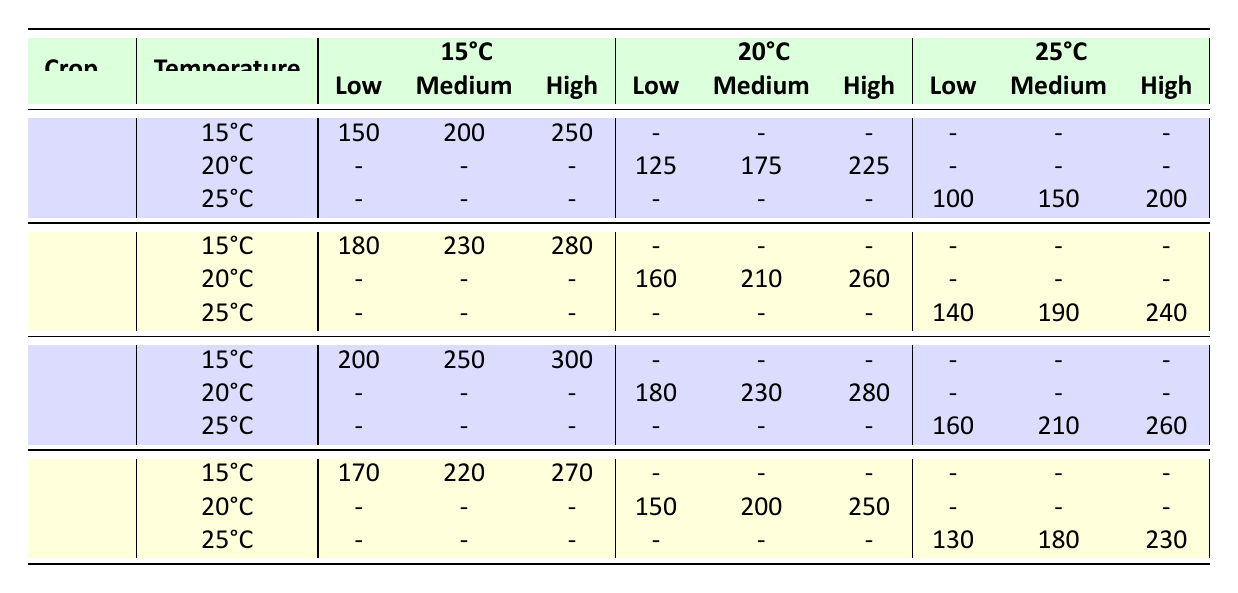What's the life expectancy of Maize under low precipitation at 15°C? According to the table, for Maize under the temperature scenario of 15°C and low precipitation, the life expectancy is 150.
Answer: 150 What is the highest life expectancy for Rice regardless of temperature or precipitation? The highest life expectancy for Rice is at 15°C with high precipitation, which is 300.
Answer: 300 Is the life expectancy of Wheat under medium precipitation at 20°C higher than that of Barley under high precipitation at 25°C? For Wheat at 20°C under medium precipitation, the life expectancy is 210. For Barley at 25°C under high precipitation, it is 230. Since 210 is less than 230, the statement is false.
Answer: No What is the difference in life expectancy for Maize between low precipitation at 15°C and medium precipitation at 20°C? For Maize at 15°C low precipitation, the life expectancy is 150. At 20°C medium precipitation, it is 175. The difference is 175 - 150 = 25.
Answer: 25 What are the life expectancies of Barley under high precipitation at 15°C and 25°C? For Barley at 15°C under high precipitation, the life expectancy is 270. At 25°C under high precipitation, it is 230.
Answer: 270 and 230 Which crop shows the largest drop in life expectancy when moving from low precipitation at 15°C to high precipitation at 25°C? For Maize, low precipitation at 15°C gives a life expectancy of 150, whereas at 25°C and high precipitation, it is 200. For Wheat, it's 180 at 15°C (low) and 240 at 25°C (high). For Rice, it's 200 at 15°C and 260 at 25°C. The largest drop occurs with Barley, from 170 at 15°C to 130 at 25°C.
Answer: Barley What is the average life expectancy for all crops at 20°C under medium precipitation? At 20°C and medium precipitation, Maize has 175, Wheat has 210, Rice has 230, and Barley has 200. Summing these, we have 175 + 210 + 230 + 200 = 815. Dividing by 4 gives an average of 203.75.
Answer: 203.75 Which crop has the same life expectancy for medium precipitation at 15°C and low precipitation at 20°C? The life expectancy for Wheat at 15°C under medium precipitation is 230, while for Barley at 20°C under low precipitation, it is 150. These two values differ. The crops do not match up.
Answer: No 